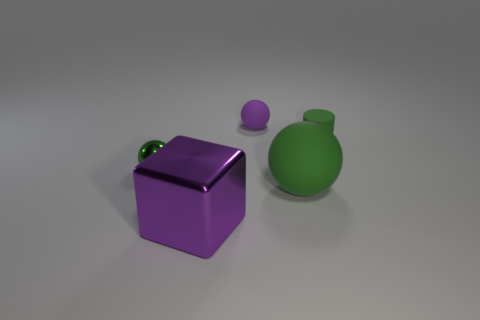Subtract all big matte balls. How many balls are left? 2 Add 4 green shiny objects. How many objects exist? 9 Subtract all purple cylinders. How many green spheres are left? 2 Add 5 green things. How many green things are left? 8 Add 3 balls. How many balls exist? 6 Subtract all purple spheres. How many spheres are left? 2 Subtract 0 yellow spheres. How many objects are left? 5 Subtract all cylinders. How many objects are left? 4 Subtract 1 cylinders. How many cylinders are left? 0 Subtract all purple cylinders. Subtract all cyan blocks. How many cylinders are left? 1 